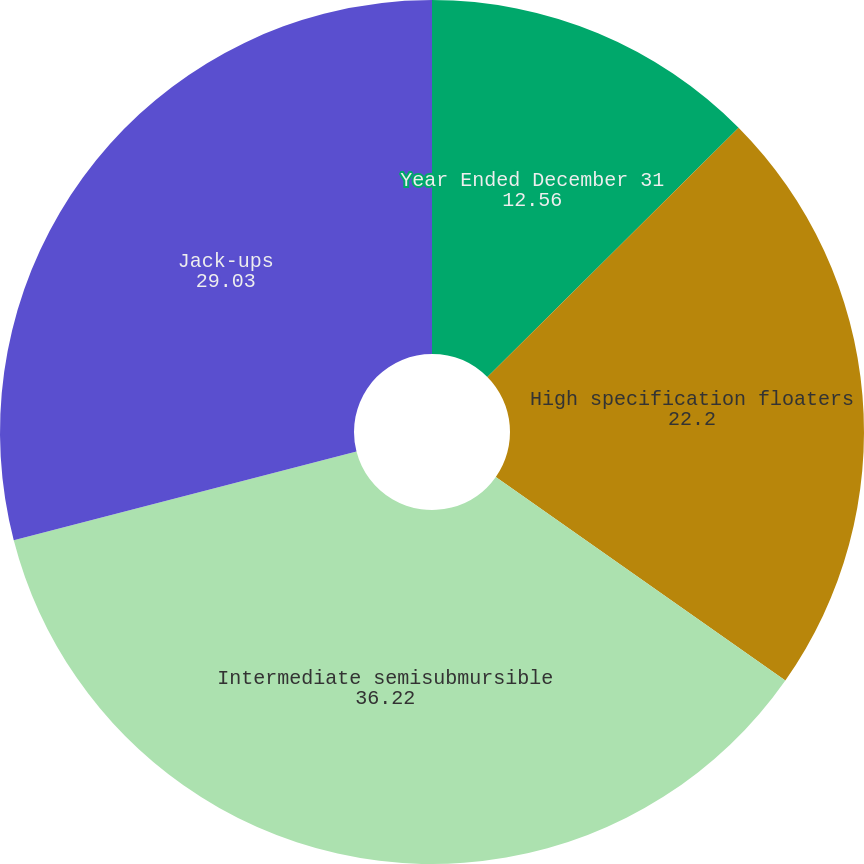<chart> <loc_0><loc_0><loc_500><loc_500><pie_chart><fcel>Year Ended December 31<fcel>High specification floaters<fcel>Intermediate semisubmursible<fcel>Jack-ups<nl><fcel>12.56%<fcel>22.2%<fcel>36.22%<fcel>29.03%<nl></chart> 